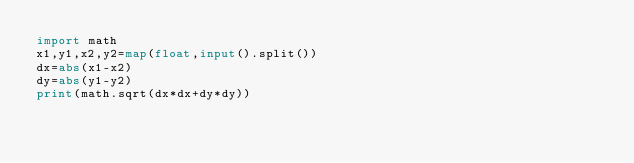Convert code to text. <code><loc_0><loc_0><loc_500><loc_500><_Python_>import math
x1,y1,x2,y2=map(float,input().split())
dx=abs(x1-x2)
dy=abs(y1-y2)
print(math.sqrt(dx*dx+dy*dy))
</code> 